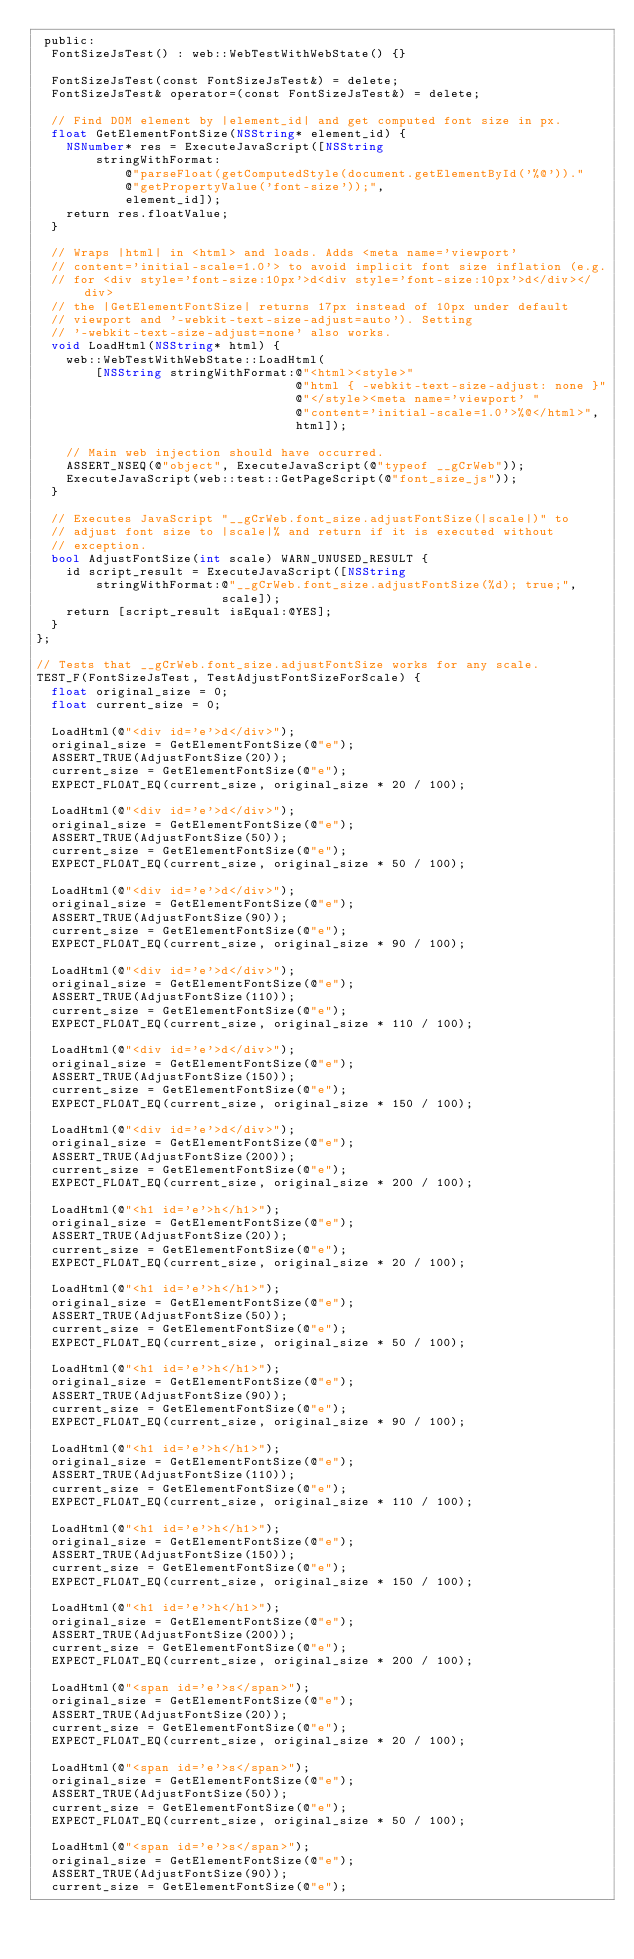Convert code to text. <code><loc_0><loc_0><loc_500><loc_500><_ObjectiveC_> public:
  FontSizeJsTest() : web::WebTestWithWebState() {}

  FontSizeJsTest(const FontSizeJsTest&) = delete;
  FontSizeJsTest& operator=(const FontSizeJsTest&) = delete;

  // Find DOM element by |element_id| and get computed font size in px.
  float GetElementFontSize(NSString* element_id) {
    NSNumber* res = ExecuteJavaScript([NSString
        stringWithFormat:
            @"parseFloat(getComputedStyle(document.getElementById('%@'))."
            @"getPropertyValue('font-size'));",
            element_id]);
    return res.floatValue;
  }

  // Wraps |html| in <html> and loads. Adds <meta name='viewport'
  // content='initial-scale=1.0'> to avoid implicit font size inflation (e.g.
  // for <div style='font-size:10px'>d<div style='font-size:10px'>d</div></div>
  // the |GetElementFontSize| returns 17px instead of 10px under default
  // viewport and '-webkit-text-size-adjust=auto'). Setting
  // '-webkit-text-size-adjust=none' also works.
  void LoadHtml(NSString* html) {
    web::WebTestWithWebState::LoadHtml(
        [NSString stringWithFormat:@"<html><style>"
                                   @"html { -webkit-text-size-adjust: none }"
                                   @"</style><meta name='viewport' "
                                   @"content='initial-scale=1.0'>%@</html>",
                                   html]);

    // Main web injection should have occurred.
    ASSERT_NSEQ(@"object", ExecuteJavaScript(@"typeof __gCrWeb"));
    ExecuteJavaScript(web::test::GetPageScript(@"font_size_js"));
  }

  // Executes JavaScript "__gCrWeb.font_size.adjustFontSize(|scale|)" to
  // adjust font size to |scale|% and return if it is executed without
  // exception.
  bool AdjustFontSize(int scale) WARN_UNUSED_RESULT {
    id script_result = ExecuteJavaScript([NSString
        stringWithFormat:@"__gCrWeb.font_size.adjustFontSize(%d); true;",
                         scale]);
    return [script_result isEqual:@YES];
  }
};

// Tests that __gCrWeb.font_size.adjustFontSize works for any scale.
TEST_F(FontSizeJsTest, TestAdjustFontSizeForScale) {
  float original_size = 0;
  float current_size = 0;

  LoadHtml(@"<div id='e'>d</div>");
  original_size = GetElementFontSize(@"e");
  ASSERT_TRUE(AdjustFontSize(20));
  current_size = GetElementFontSize(@"e");
  EXPECT_FLOAT_EQ(current_size, original_size * 20 / 100);

  LoadHtml(@"<div id='e'>d</div>");
  original_size = GetElementFontSize(@"e");
  ASSERT_TRUE(AdjustFontSize(50));
  current_size = GetElementFontSize(@"e");
  EXPECT_FLOAT_EQ(current_size, original_size * 50 / 100);

  LoadHtml(@"<div id='e'>d</div>");
  original_size = GetElementFontSize(@"e");
  ASSERT_TRUE(AdjustFontSize(90));
  current_size = GetElementFontSize(@"e");
  EXPECT_FLOAT_EQ(current_size, original_size * 90 / 100);

  LoadHtml(@"<div id='e'>d</div>");
  original_size = GetElementFontSize(@"e");
  ASSERT_TRUE(AdjustFontSize(110));
  current_size = GetElementFontSize(@"e");
  EXPECT_FLOAT_EQ(current_size, original_size * 110 / 100);

  LoadHtml(@"<div id='e'>d</div>");
  original_size = GetElementFontSize(@"e");
  ASSERT_TRUE(AdjustFontSize(150));
  current_size = GetElementFontSize(@"e");
  EXPECT_FLOAT_EQ(current_size, original_size * 150 / 100);

  LoadHtml(@"<div id='e'>d</div>");
  original_size = GetElementFontSize(@"e");
  ASSERT_TRUE(AdjustFontSize(200));
  current_size = GetElementFontSize(@"e");
  EXPECT_FLOAT_EQ(current_size, original_size * 200 / 100);

  LoadHtml(@"<h1 id='e'>h</h1>");
  original_size = GetElementFontSize(@"e");
  ASSERT_TRUE(AdjustFontSize(20));
  current_size = GetElementFontSize(@"e");
  EXPECT_FLOAT_EQ(current_size, original_size * 20 / 100);

  LoadHtml(@"<h1 id='e'>h</h1>");
  original_size = GetElementFontSize(@"e");
  ASSERT_TRUE(AdjustFontSize(50));
  current_size = GetElementFontSize(@"e");
  EXPECT_FLOAT_EQ(current_size, original_size * 50 / 100);

  LoadHtml(@"<h1 id='e'>h</h1>");
  original_size = GetElementFontSize(@"e");
  ASSERT_TRUE(AdjustFontSize(90));
  current_size = GetElementFontSize(@"e");
  EXPECT_FLOAT_EQ(current_size, original_size * 90 / 100);

  LoadHtml(@"<h1 id='e'>h</h1>");
  original_size = GetElementFontSize(@"e");
  ASSERT_TRUE(AdjustFontSize(110));
  current_size = GetElementFontSize(@"e");
  EXPECT_FLOAT_EQ(current_size, original_size * 110 / 100);

  LoadHtml(@"<h1 id='e'>h</h1>");
  original_size = GetElementFontSize(@"e");
  ASSERT_TRUE(AdjustFontSize(150));
  current_size = GetElementFontSize(@"e");
  EXPECT_FLOAT_EQ(current_size, original_size * 150 / 100);

  LoadHtml(@"<h1 id='e'>h</h1>");
  original_size = GetElementFontSize(@"e");
  ASSERT_TRUE(AdjustFontSize(200));
  current_size = GetElementFontSize(@"e");
  EXPECT_FLOAT_EQ(current_size, original_size * 200 / 100);

  LoadHtml(@"<span id='e'>s</span>");
  original_size = GetElementFontSize(@"e");
  ASSERT_TRUE(AdjustFontSize(20));
  current_size = GetElementFontSize(@"e");
  EXPECT_FLOAT_EQ(current_size, original_size * 20 / 100);

  LoadHtml(@"<span id='e'>s</span>");
  original_size = GetElementFontSize(@"e");
  ASSERT_TRUE(AdjustFontSize(50));
  current_size = GetElementFontSize(@"e");
  EXPECT_FLOAT_EQ(current_size, original_size * 50 / 100);

  LoadHtml(@"<span id='e'>s</span>");
  original_size = GetElementFontSize(@"e");
  ASSERT_TRUE(AdjustFontSize(90));
  current_size = GetElementFontSize(@"e");</code> 